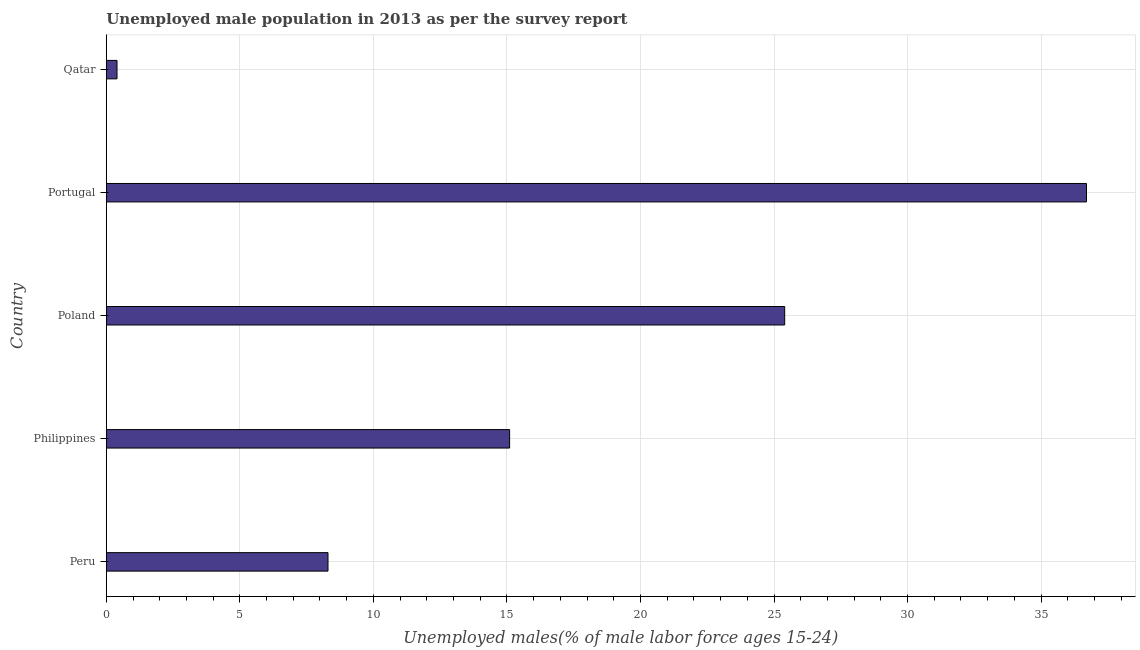Does the graph contain any zero values?
Provide a short and direct response. No. What is the title of the graph?
Make the answer very short. Unemployed male population in 2013 as per the survey report. What is the label or title of the X-axis?
Provide a short and direct response. Unemployed males(% of male labor force ages 15-24). What is the unemployed male youth in Poland?
Provide a succinct answer. 25.4. Across all countries, what is the maximum unemployed male youth?
Your response must be concise. 36.7. Across all countries, what is the minimum unemployed male youth?
Make the answer very short. 0.4. In which country was the unemployed male youth maximum?
Offer a very short reply. Portugal. In which country was the unemployed male youth minimum?
Keep it short and to the point. Qatar. What is the sum of the unemployed male youth?
Make the answer very short. 85.9. What is the difference between the unemployed male youth in Philippines and Portugal?
Offer a terse response. -21.6. What is the average unemployed male youth per country?
Make the answer very short. 17.18. What is the median unemployed male youth?
Offer a terse response. 15.1. In how many countries, is the unemployed male youth greater than 15 %?
Provide a short and direct response. 3. What is the ratio of the unemployed male youth in Philippines to that in Portugal?
Your response must be concise. 0.41. Is the unemployed male youth in Peru less than that in Qatar?
Make the answer very short. No. What is the difference between the highest and the lowest unemployed male youth?
Your answer should be compact. 36.3. In how many countries, is the unemployed male youth greater than the average unemployed male youth taken over all countries?
Your answer should be very brief. 2. How many bars are there?
Provide a short and direct response. 5. What is the difference between two consecutive major ticks on the X-axis?
Offer a terse response. 5. What is the Unemployed males(% of male labor force ages 15-24) of Peru?
Keep it short and to the point. 8.3. What is the Unemployed males(% of male labor force ages 15-24) of Philippines?
Provide a succinct answer. 15.1. What is the Unemployed males(% of male labor force ages 15-24) of Poland?
Offer a very short reply. 25.4. What is the Unemployed males(% of male labor force ages 15-24) of Portugal?
Keep it short and to the point. 36.7. What is the Unemployed males(% of male labor force ages 15-24) in Qatar?
Offer a terse response. 0.4. What is the difference between the Unemployed males(% of male labor force ages 15-24) in Peru and Poland?
Give a very brief answer. -17.1. What is the difference between the Unemployed males(% of male labor force ages 15-24) in Peru and Portugal?
Keep it short and to the point. -28.4. What is the difference between the Unemployed males(% of male labor force ages 15-24) in Philippines and Poland?
Your answer should be compact. -10.3. What is the difference between the Unemployed males(% of male labor force ages 15-24) in Philippines and Portugal?
Provide a succinct answer. -21.6. What is the difference between the Unemployed males(% of male labor force ages 15-24) in Poland and Portugal?
Make the answer very short. -11.3. What is the difference between the Unemployed males(% of male labor force ages 15-24) in Portugal and Qatar?
Provide a short and direct response. 36.3. What is the ratio of the Unemployed males(% of male labor force ages 15-24) in Peru to that in Philippines?
Provide a short and direct response. 0.55. What is the ratio of the Unemployed males(% of male labor force ages 15-24) in Peru to that in Poland?
Make the answer very short. 0.33. What is the ratio of the Unemployed males(% of male labor force ages 15-24) in Peru to that in Portugal?
Provide a short and direct response. 0.23. What is the ratio of the Unemployed males(% of male labor force ages 15-24) in Peru to that in Qatar?
Your response must be concise. 20.75. What is the ratio of the Unemployed males(% of male labor force ages 15-24) in Philippines to that in Poland?
Your answer should be very brief. 0.59. What is the ratio of the Unemployed males(% of male labor force ages 15-24) in Philippines to that in Portugal?
Your response must be concise. 0.41. What is the ratio of the Unemployed males(% of male labor force ages 15-24) in Philippines to that in Qatar?
Give a very brief answer. 37.75. What is the ratio of the Unemployed males(% of male labor force ages 15-24) in Poland to that in Portugal?
Give a very brief answer. 0.69. What is the ratio of the Unemployed males(% of male labor force ages 15-24) in Poland to that in Qatar?
Your response must be concise. 63.5. What is the ratio of the Unemployed males(% of male labor force ages 15-24) in Portugal to that in Qatar?
Offer a terse response. 91.75. 